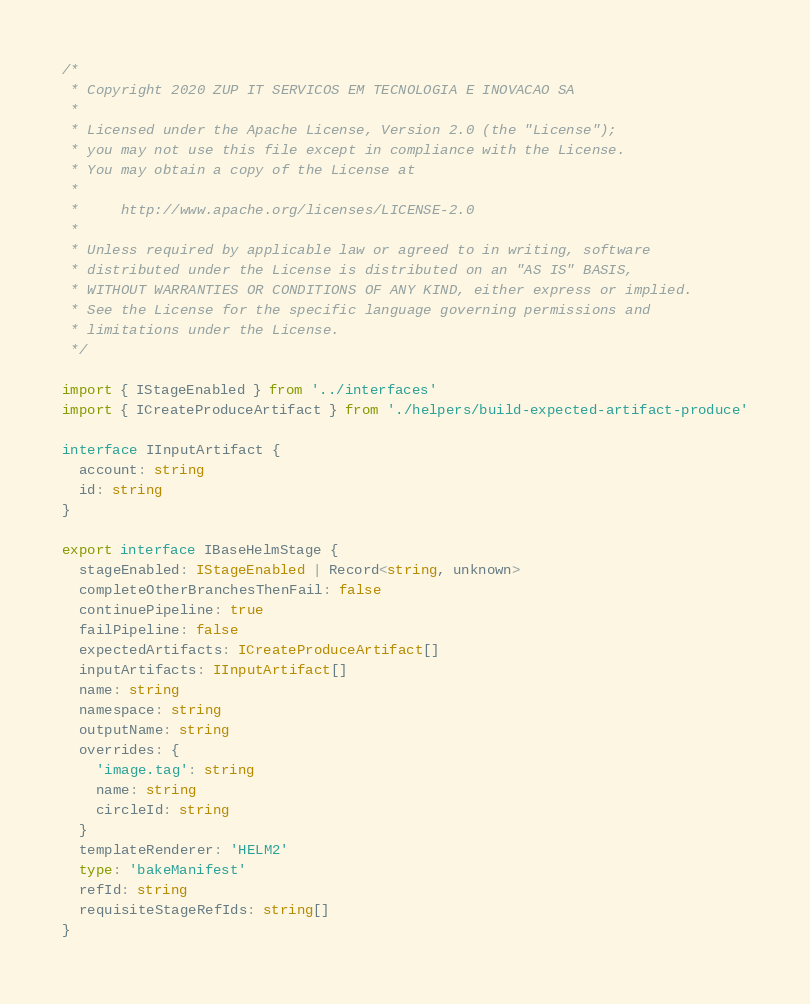Convert code to text. <code><loc_0><loc_0><loc_500><loc_500><_TypeScript_>/*
 * Copyright 2020 ZUP IT SERVICOS EM TECNOLOGIA E INOVACAO SA
 *
 * Licensed under the Apache License, Version 2.0 (the "License");
 * you may not use this file except in compliance with the License.
 * You may obtain a copy of the License at
 *
 *     http://www.apache.org/licenses/LICENSE-2.0
 *
 * Unless required by applicable law or agreed to in writing, software
 * distributed under the License is distributed on an "AS IS" BASIS,
 * WITHOUT WARRANTIES OR CONDITIONS OF ANY KIND, either express or implied.
 * See the License for the specific language governing permissions and
 * limitations under the License.
 */

import { IStageEnabled } from '../interfaces'
import { ICreateProduceArtifact } from './helpers/build-expected-artifact-produce'

interface IInputArtifact {
  account: string
  id: string
}

export interface IBaseHelmStage {
  stageEnabled: IStageEnabled | Record<string, unknown>
  completeOtherBranchesThenFail: false
  continuePipeline: true
  failPipeline: false
  expectedArtifacts: ICreateProduceArtifact[]
  inputArtifacts: IInputArtifact[]
  name: string
  namespace: string
  outputName: string
  overrides: {
    'image.tag': string
    name: string
    circleId: string
  }
  templateRenderer: 'HELM2'
  type: 'bakeManifest'
  refId: string
  requisiteStageRefIds: string[]
}
</code> 